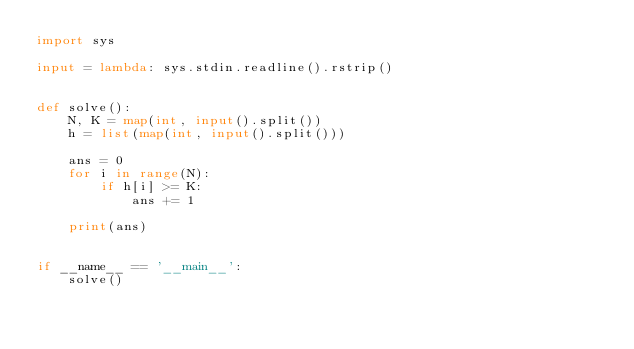Convert code to text. <code><loc_0><loc_0><loc_500><loc_500><_Python_>import sys

input = lambda: sys.stdin.readline().rstrip()


def solve():
    N, K = map(int, input().split())
    h = list(map(int, input().split()))

    ans = 0
    for i in range(N):
        if h[i] >= K:
            ans += 1

    print(ans)


if __name__ == '__main__':
    solve()
</code> 